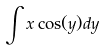<formula> <loc_0><loc_0><loc_500><loc_500>\int x \cos ( y ) d y</formula> 